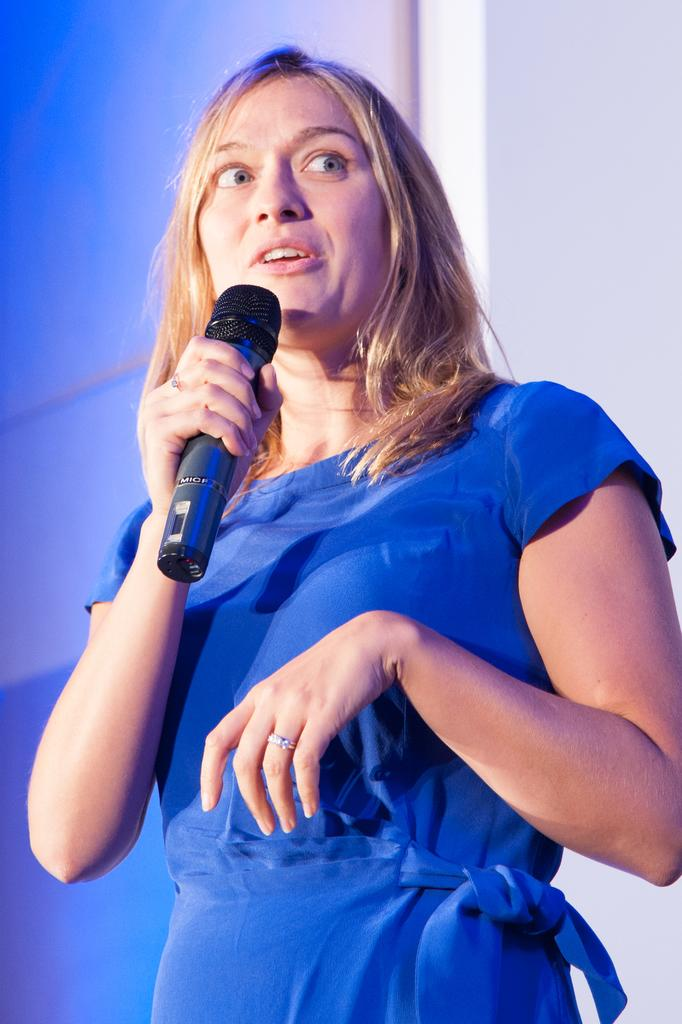What is the main subject of the image? The main subject of the image is a woman. What is the woman doing in the image? The woman is standing and holding a microphone. What is the woman wearing in the image? The woman is wearing a blue dress. What is the color of the woman's hair? The woman has golden hair. What can be seen in the background of the image? There is a blue color wall in the background of the image. What type of calculator is the woman using in the image? There is no calculator present in the image; the woman is holding a microphone. What account does the woman have in the image? There is no mention of an account in the image; the focus is on the woman holding a microphone and her appearance. 